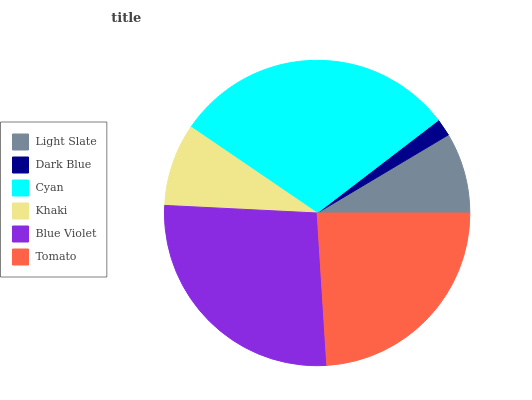Is Dark Blue the minimum?
Answer yes or no. Yes. Is Cyan the maximum?
Answer yes or no. Yes. Is Cyan the minimum?
Answer yes or no. No. Is Dark Blue the maximum?
Answer yes or no. No. Is Cyan greater than Dark Blue?
Answer yes or no. Yes. Is Dark Blue less than Cyan?
Answer yes or no. Yes. Is Dark Blue greater than Cyan?
Answer yes or no. No. Is Cyan less than Dark Blue?
Answer yes or no. No. Is Tomato the high median?
Answer yes or no. Yes. Is Khaki the low median?
Answer yes or no. Yes. Is Blue Violet the high median?
Answer yes or no. No. Is Tomato the low median?
Answer yes or no. No. 